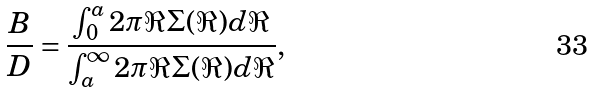<formula> <loc_0><loc_0><loc_500><loc_500>\frac { B } { D } = \frac { \int _ { 0 } ^ { a } 2 \pi \Re \Sigma ( \Re ) d \Re } { \int _ { a } ^ { \infty } 2 \pi \Re \Sigma ( \Re ) d \Re } ,</formula> 